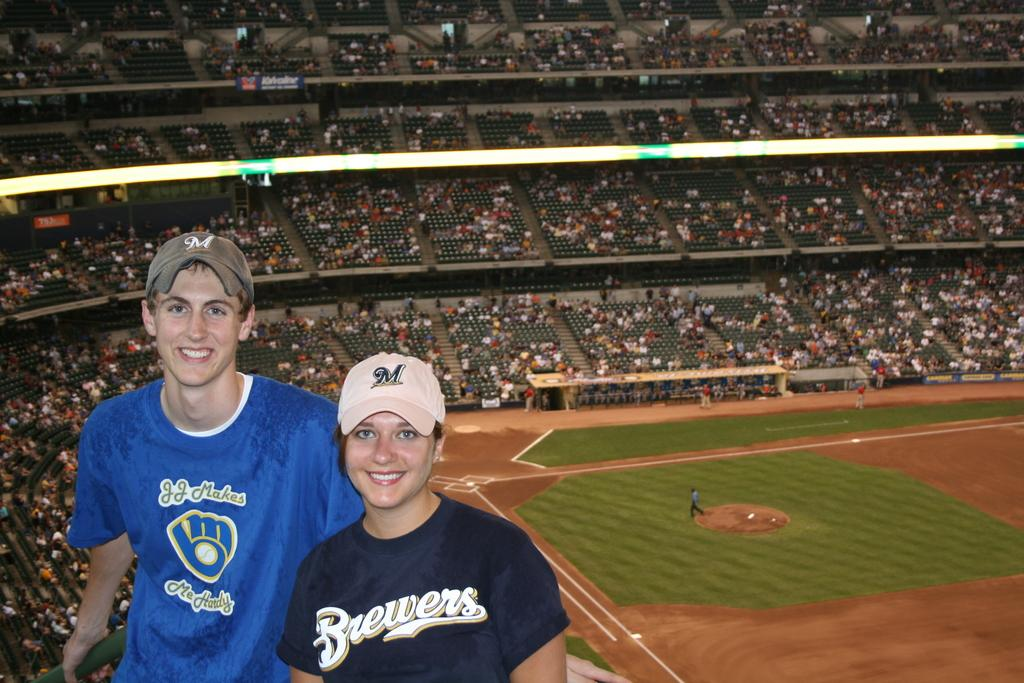<image>
Present a compact description of the photo's key features. The couple is wearing Brewers shirts and hats 